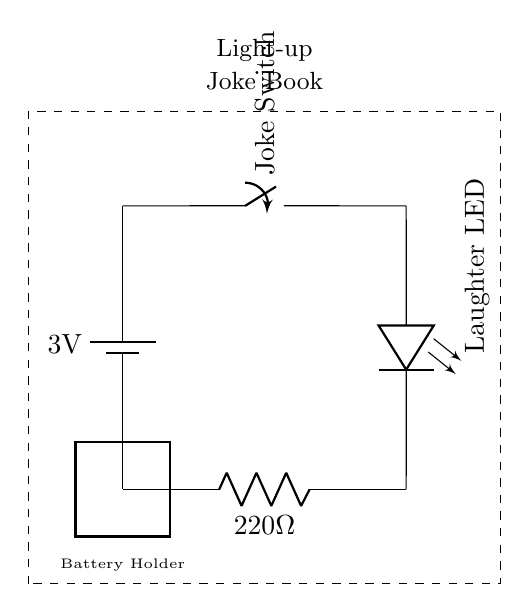What is the voltage of the battery? The battery is labeled as providing 3 volts, which is the potential difference supplied to the circuit.
Answer: 3 volts What component controls the flow of current? The switch is the component that controls whether or not the current flows through the circuit. When the switch is closed, the circuit is complete, allowing current to flow; when open, it stops the current.
Answer: Switch What is the resistance value in this circuit? The resistor is labeled as 220 ohms, which limits the current through the LED to safe levels.
Answer: 220 ohms Which component lights up when the switch is closed? The LED is specified as the "Laughter LED" and it will emit light when current flows through it, which occurs when the switch is closed.
Answer: LED What is the purpose of the resistor in this circuit? The resistor is used to limit the current going through the LED to prevent it from burning out. This is crucial as LEDs are sensitive to overcurrent.
Answer: Limit current In what configuration are the components connected? The components are connected in series, meaning that the current flows through each component one after the other without any branching paths.
Answer: Series What does the dashed rectangle represent? The dashed rectangle signifies the bounds of the light-up joke book, indicating where the electronic components are integrated into the book setup.
Answer: Light-up joke book 